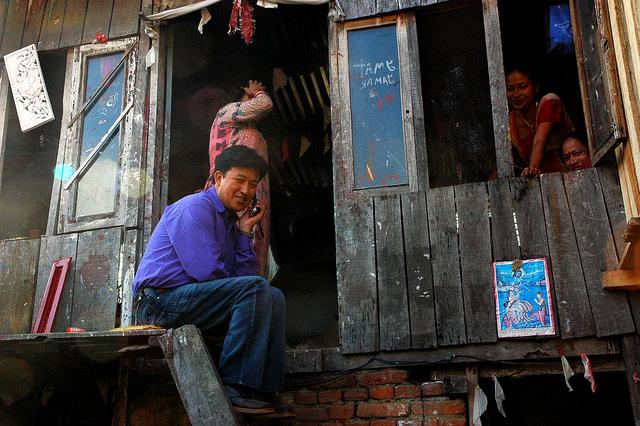What is the man in the blue shirt doing?
Be succinct. Talking on phone. Where is the man sitting at?
Quick response, please. Porch. What color is the wood?
Answer briefly. Brown. 